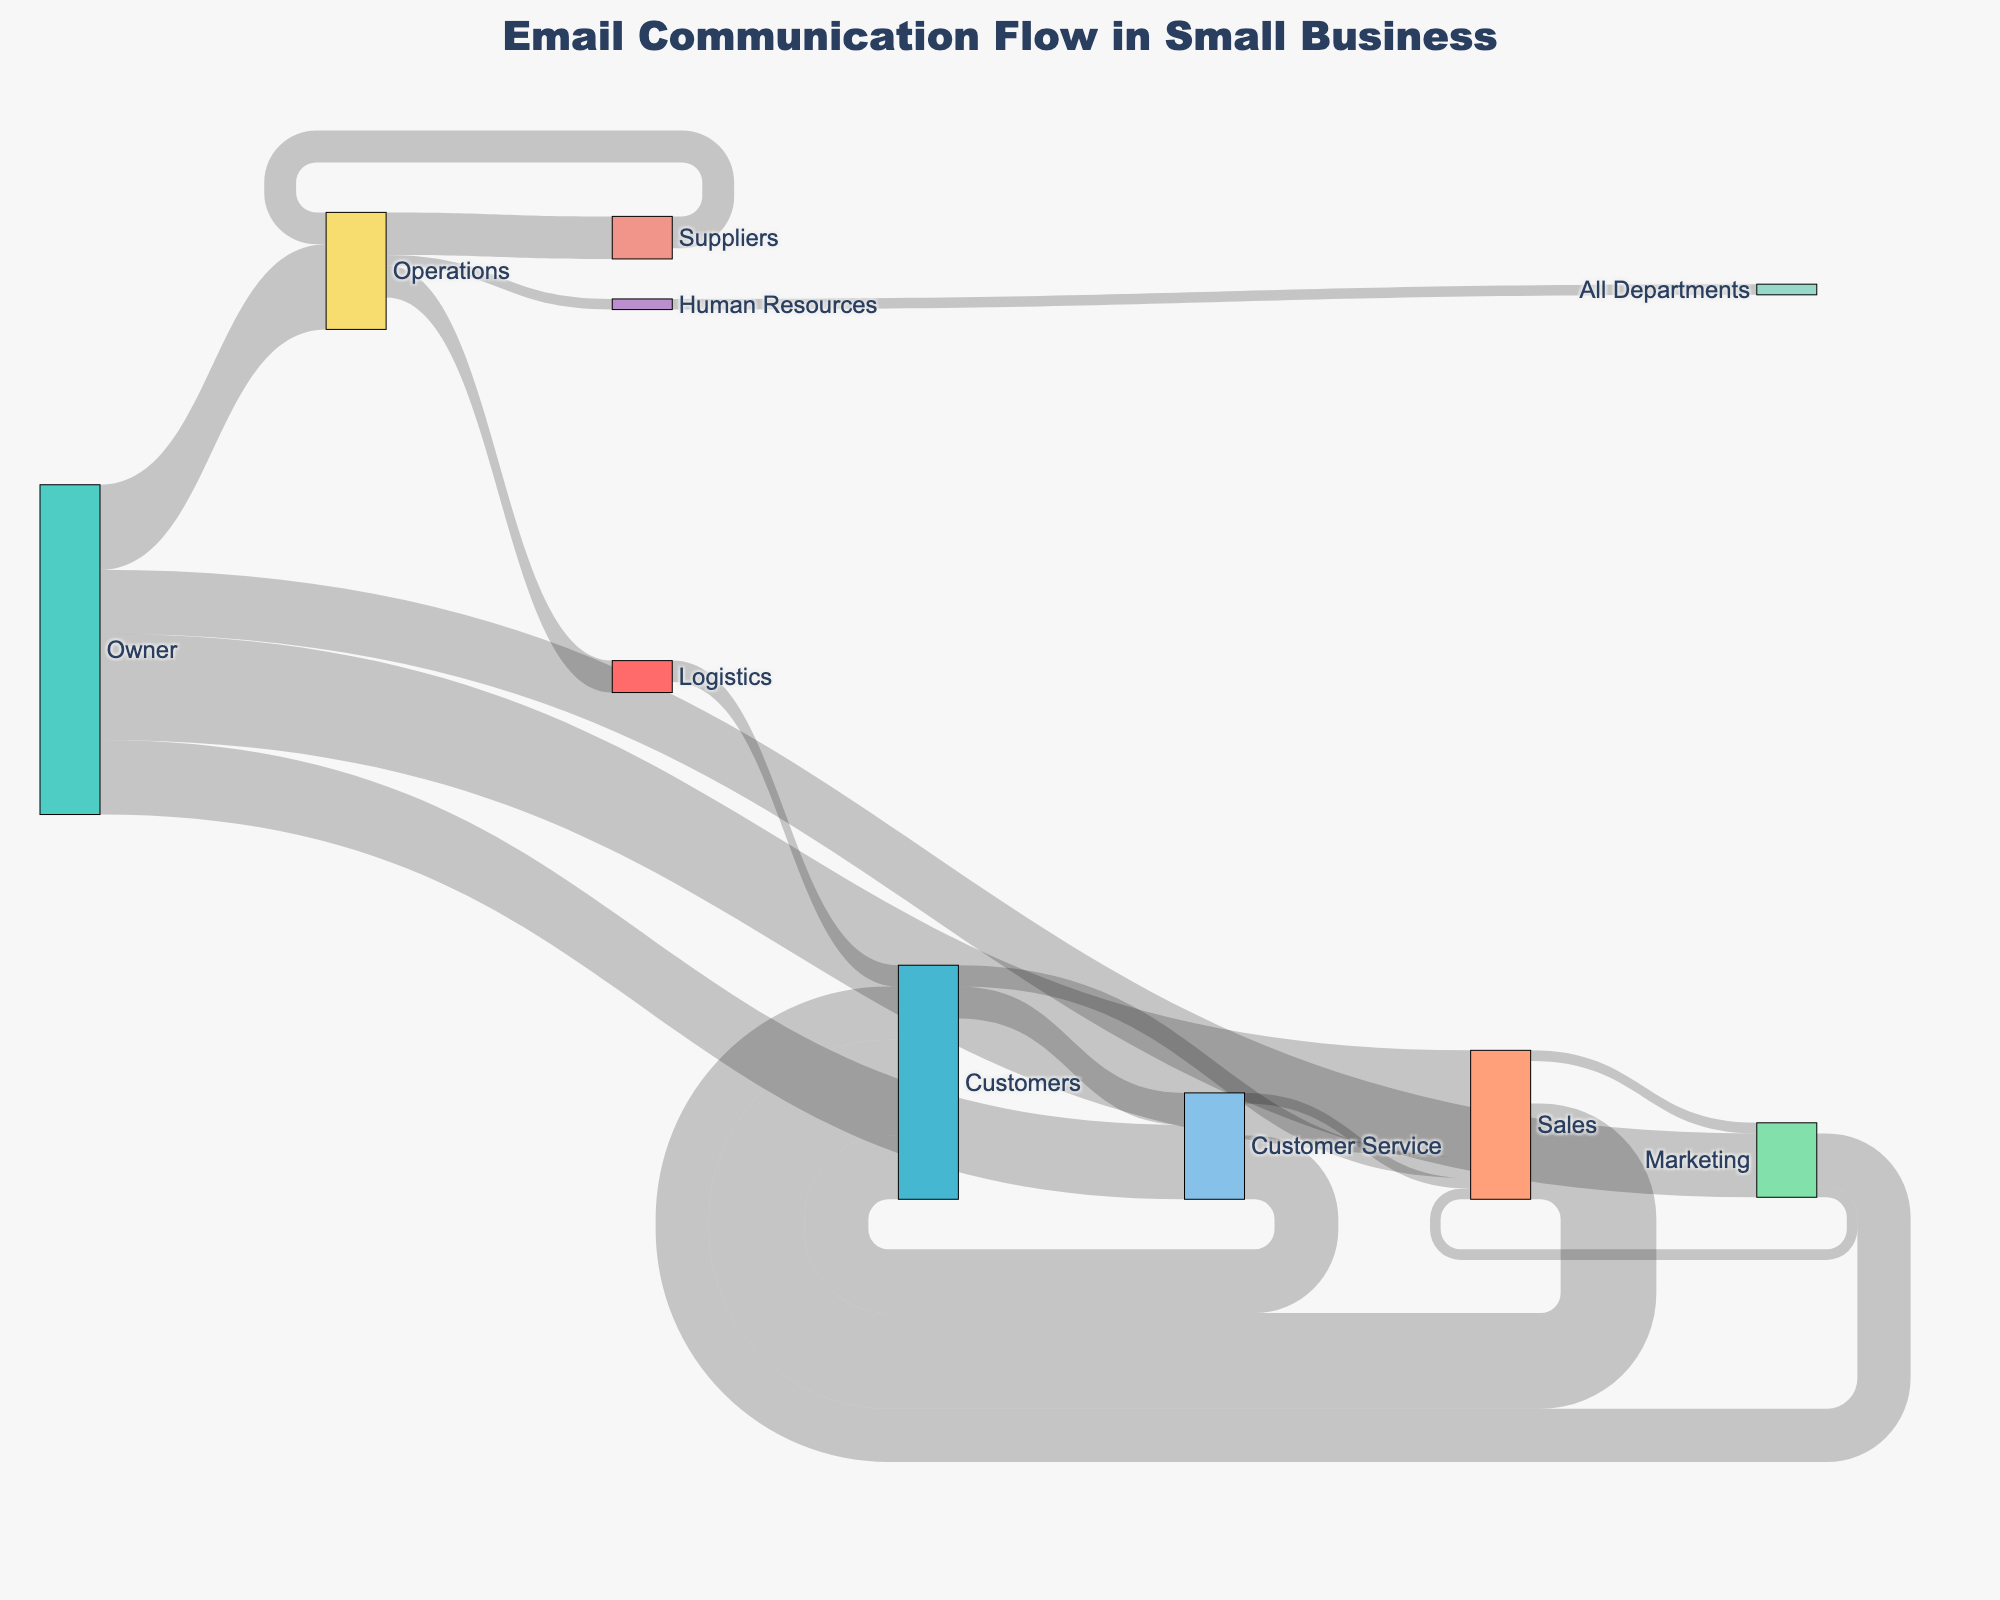What department receives the most emails from the Owner? To identify the department that receives the most emails, look for the thickest flow originating from the Owner. The values indicate email volumes. The Sales department receives the most emails from the Owner.
Answer: Sales How many emails are sent from Customer Service to Customers? Locate the flow from Customer Service to Customers and check the value assigned to it. The value of emails sent is indicated by the number on the flow line.
Answer: 30 What is the total number of emails sent from the Owner to all departments? Sum the values for all flows originating from the Owner: Sales (50), Marketing (30), Operations (40), and Customer Service (35). The total is 50 + 30 + 40 + 35.
Answer: 155 Which department sends emails to the most other departments? Find the department with the highest number of outgoing flows. Both Operations and Marketing send emails to three different departments, but Sales sends to only two and Customer Service to one.
Answer: Operations What is the total number of emails reaching Customers from all departments? Sum all flows that end at Customers: Sales (45), Marketing (25), Customer Service (30), and Logistics (10). The total is 45 + 25 + 30 + 10.
Answer: 110 How many emails are exchanged between Sales and Marketing? Identify the flows between Sales and Marketing in both directions, Sales to Marketing (5) and Marketing to Sales (5), then add them. The total is 5 + 5.
Answer: 10 Which department interacts the most with Customers? Find the department with the highest number of emails sent to Customers. Sales sends 45, Marketing sends 25, Customer Service sends 30, and Logistics sends 10, where Sales has the highest, 45.
Answer: Sales If we combine the email flows from Operations to Suppliers, Logistics, and Human Resources, how many emails does Operations send in total? Add the values of the flows from Operations to Suppliers (20), Logistics (15), and Human Resources (5). The total is 20 + 15 + 5.
Answer: 40 What is the minimum number of emails exchanged between any two entities? Find the smallest flow value in the dataset. The smallest flows are from Operations to Human Resources (5), Sales to Marketing (5), and several others, each valued at 5.
Answer: 5 Which department receives the fewest emails from external sources (Customers, Suppliers)? Compare the incoming emails from external sources to each department: Sales (Customers: 10), Customer Service (Customers: 15), Operations (Suppliers: 15). Customer Service receives the fewest, which is 15.
Answer: Customer Service 